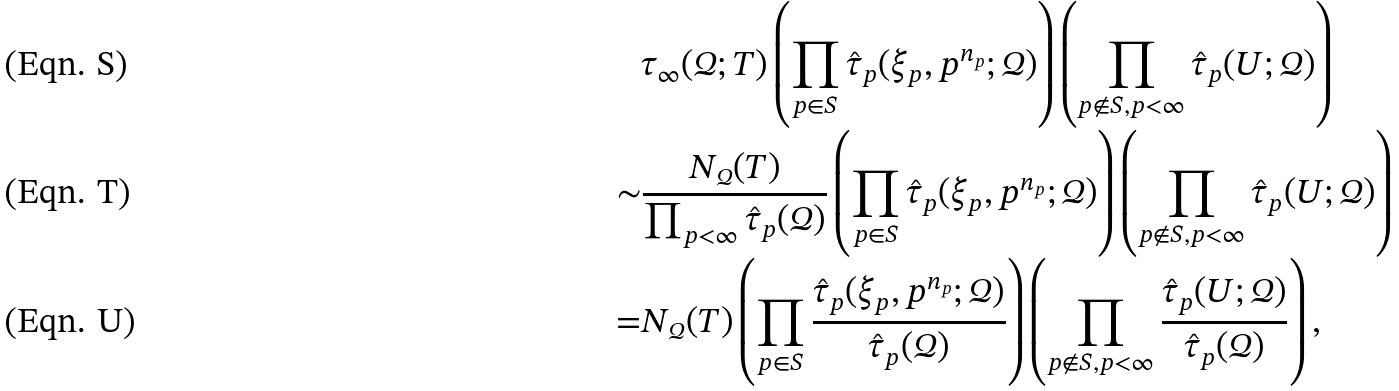<formula> <loc_0><loc_0><loc_500><loc_500>& \tau _ { \infty } ( \mathcal { Q } ; T ) \left ( \prod _ { p \in S } \hat { \tau } _ { p } ( \xi _ { p } , p ^ { n _ { p } } ; \mathcal { Q } ) \right ) \left ( \prod _ { p \not \in S , p < \infty } \hat { \tau } _ { p } ( U ; \mathcal { Q } ) \right ) \\ \sim & \frac { N _ { \mathcal { Q } } ( T ) } { \prod _ { p < \infty } \hat { \tau } _ { p } ( \mathcal { Q } ) } \left ( \prod _ { p \in S } \hat { \tau } _ { p } ( \xi _ { p } , p ^ { n _ { p } } ; \mathcal { Q } ) \right ) \left ( \prod _ { p \not \in S , p < \infty } \hat { \tau } _ { p } ( U ; \mathcal { Q } ) \right ) \\ = & N _ { \mathcal { Q } } ( T ) \left ( \prod _ { p \in S } \frac { \hat { \tau } _ { p } ( \xi _ { p } , p ^ { n _ { p } } ; \mathcal { Q } ) } { \hat { \tau } _ { p } ( \mathcal { Q } ) } \right ) \left ( \prod _ { p \not \in S , p < \infty } \frac { \hat { \tau } _ { p } ( U ; \mathcal { Q } ) } { \hat { \tau } _ { p } ( \mathcal { Q } ) } \right ) ,</formula> 